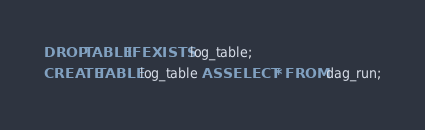<code> <loc_0><loc_0><loc_500><loc_500><_SQL_>DROP TABLE IF EXISTS log_table;
CREATE TABLE log_table AS SELECT * FROM dag_run;</code> 